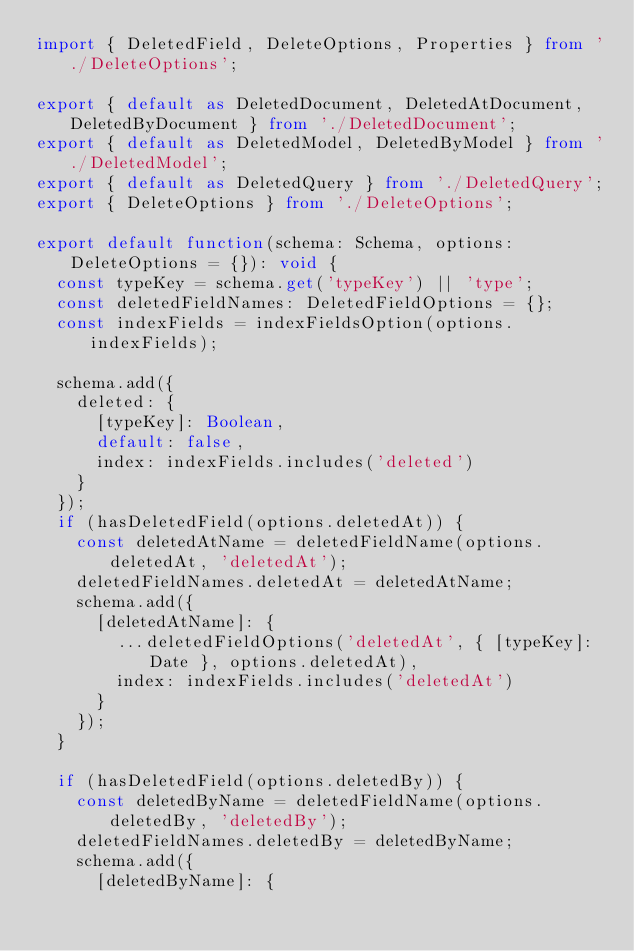Convert code to text. <code><loc_0><loc_0><loc_500><loc_500><_TypeScript_>import { DeletedField, DeleteOptions, Properties } from './DeleteOptions';

export { default as DeletedDocument, DeletedAtDocument, DeletedByDocument } from './DeletedDocument';
export { default as DeletedModel, DeletedByModel } from './DeletedModel';
export { default as DeletedQuery } from './DeletedQuery';
export { DeleteOptions } from './DeleteOptions';

export default function(schema: Schema, options: DeleteOptions = {}): void {
	const typeKey = schema.get('typeKey') || 'type';
	const deletedFieldNames: DeletedFieldOptions = {};
	const indexFields = indexFieldsOption(options.indexFields);

	schema.add({
		deleted: {
			[typeKey]: Boolean,
			default: false,
			index: indexFields.includes('deleted')
		}
	});
	if (hasDeletedField(options.deletedAt)) {
		const deletedAtName = deletedFieldName(options.deletedAt, 'deletedAt');
		deletedFieldNames.deletedAt = deletedAtName;
		schema.add({
			[deletedAtName]: {
				...deletedFieldOptions('deletedAt', { [typeKey]: Date }, options.deletedAt),
				index: indexFields.includes('deletedAt')
			}
		});
	}

	if (hasDeletedField(options.deletedBy)) {
		const deletedByName = deletedFieldName(options.deletedBy, 'deletedBy');
		deletedFieldNames.deletedBy = deletedByName;
		schema.add({
			[deletedByName]: {</code> 